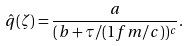<formula> <loc_0><loc_0><loc_500><loc_500>\hat { q } ( \zeta ) = \frac { a } { ( b + \tau / ( 1 f m / c ) ) ^ { c } } .</formula> 